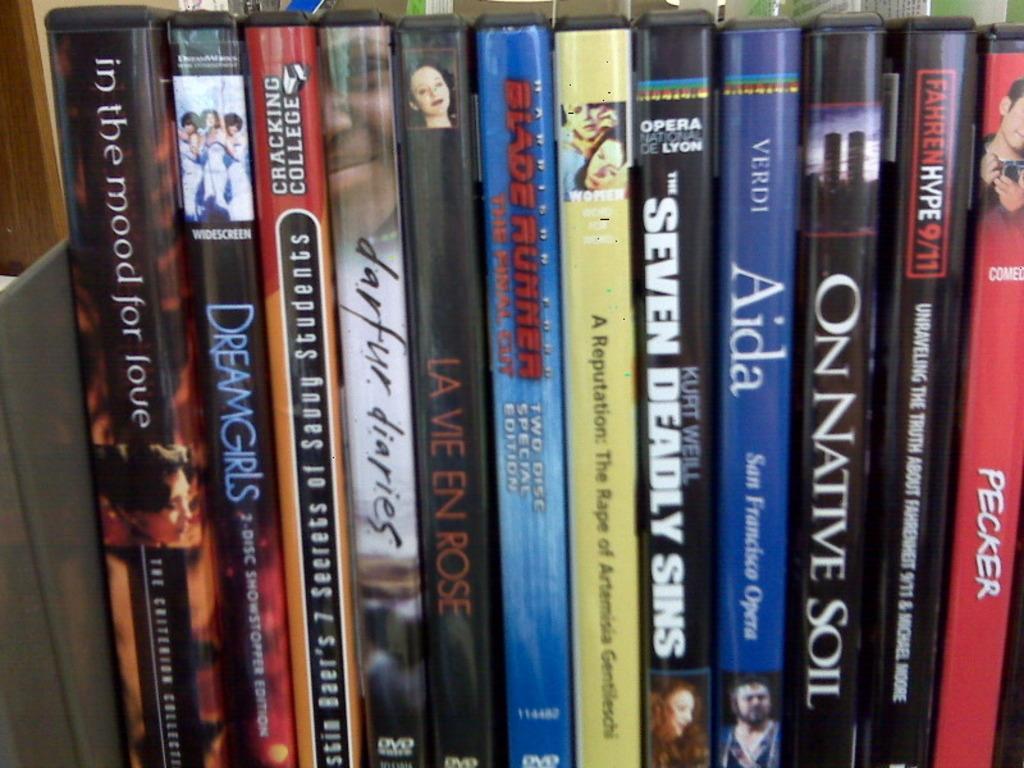In one or two sentences, can you explain what this image depicts? The picture consists of books in a bookshelf. At the top, in the background there are books. 